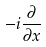Convert formula to latex. <formula><loc_0><loc_0><loc_500><loc_500>- i \frac { \partial } { \partial x }</formula> 